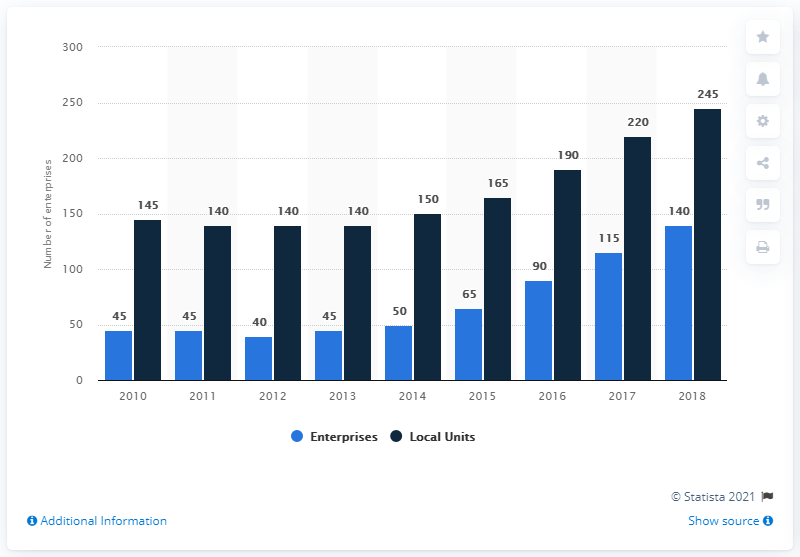Draw attention to some important aspects in this diagram. There were 245 distilling-related local units in Scotland in 2018. In 2018, there were 140 distilling-related enterprises operating in Scotland. 